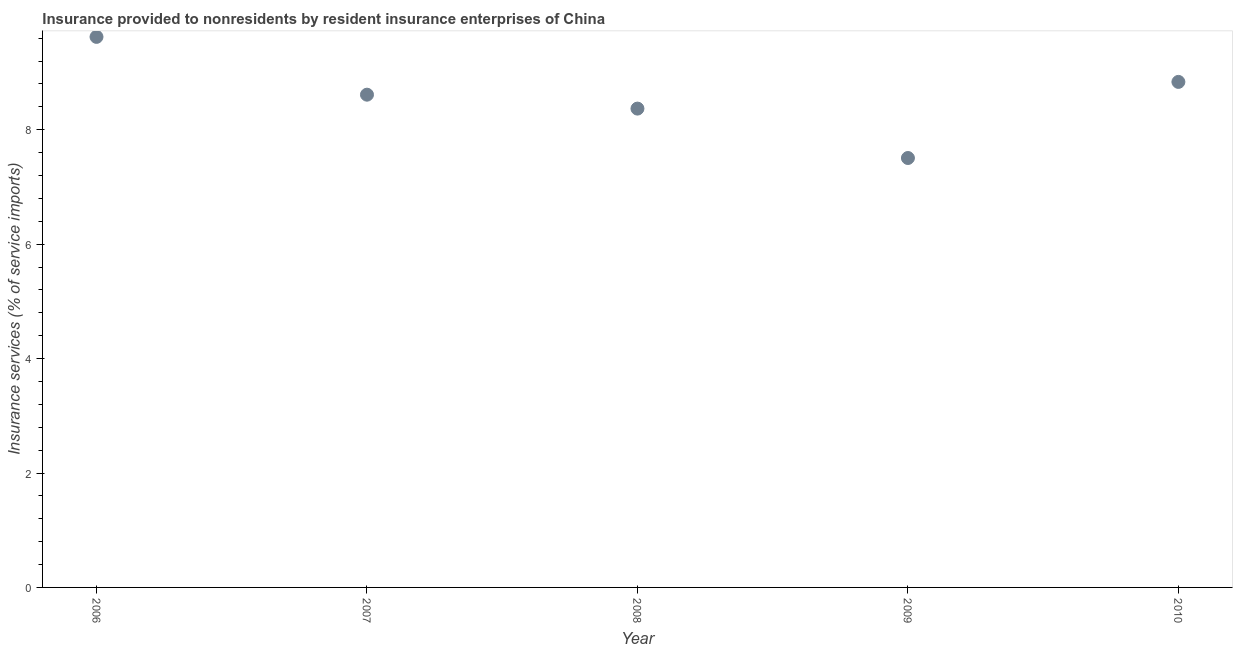What is the insurance and financial services in 2010?
Give a very brief answer. 8.84. Across all years, what is the maximum insurance and financial services?
Your answer should be compact. 9.62. Across all years, what is the minimum insurance and financial services?
Keep it short and to the point. 7.51. What is the sum of the insurance and financial services?
Provide a succinct answer. 42.95. What is the difference between the insurance and financial services in 2007 and 2009?
Offer a terse response. 1.11. What is the average insurance and financial services per year?
Offer a terse response. 8.59. What is the median insurance and financial services?
Your answer should be compact. 8.61. In how many years, is the insurance and financial services greater than 6.8 %?
Keep it short and to the point. 5. What is the ratio of the insurance and financial services in 2007 to that in 2008?
Your answer should be compact. 1.03. What is the difference between the highest and the second highest insurance and financial services?
Your answer should be very brief. 0.79. Is the sum of the insurance and financial services in 2009 and 2010 greater than the maximum insurance and financial services across all years?
Your answer should be very brief. Yes. What is the difference between the highest and the lowest insurance and financial services?
Provide a short and direct response. 2.12. How many dotlines are there?
Provide a succinct answer. 1. How many years are there in the graph?
Offer a very short reply. 5. Are the values on the major ticks of Y-axis written in scientific E-notation?
Give a very brief answer. No. Does the graph contain grids?
Give a very brief answer. No. What is the title of the graph?
Keep it short and to the point. Insurance provided to nonresidents by resident insurance enterprises of China. What is the label or title of the X-axis?
Make the answer very short. Year. What is the label or title of the Y-axis?
Provide a short and direct response. Insurance services (% of service imports). What is the Insurance services (% of service imports) in 2006?
Provide a short and direct response. 9.62. What is the Insurance services (% of service imports) in 2007?
Offer a very short reply. 8.61. What is the Insurance services (% of service imports) in 2008?
Your answer should be compact. 8.37. What is the Insurance services (% of service imports) in 2009?
Your response must be concise. 7.51. What is the Insurance services (% of service imports) in 2010?
Ensure brevity in your answer.  8.84. What is the difference between the Insurance services (% of service imports) in 2006 and 2007?
Make the answer very short. 1.01. What is the difference between the Insurance services (% of service imports) in 2006 and 2008?
Your answer should be very brief. 1.25. What is the difference between the Insurance services (% of service imports) in 2006 and 2009?
Offer a terse response. 2.12. What is the difference between the Insurance services (% of service imports) in 2006 and 2010?
Give a very brief answer. 0.79. What is the difference between the Insurance services (% of service imports) in 2007 and 2008?
Your answer should be very brief. 0.24. What is the difference between the Insurance services (% of service imports) in 2007 and 2009?
Make the answer very short. 1.11. What is the difference between the Insurance services (% of service imports) in 2007 and 2010?
Your response must be concise. -0.22. What is the difference between the Insurance services (% of service imports) in 2008 and 2009?
Ensure brevity in your answer.  0.86. What is the difference between the Insurance services (% of service imports) in 2008 and 2010?
Provide a short and direct response. -0.47. What is the difference between the Insurance services (% of service imports) in 2009 and 2010?
Provide a short and direct response. -1.33. What is the ratio of the Insurance services (% of service imports) in 2006 to that in 2007?
Offer a terse response. 1.12. What is the ratio of the Insurance services (% of service imports) in 2006 to that in 2008?
Give a very brief answer. 1.15. What is the ratio of the Insurance services (% of service imports) in 2006 to that in 2009?
Your answer should be very brief. 1.28. What is the ratio of the Insurance services (% of service imports) in 2006 to that in 2010?
Your response must be concise. 1.09. What is the ratio of the Insurance services (% of service imports) in 2007 to that in 2008?
Your answer should be compact. 1.03. What is the ratio of the Insurance services (% of service imports) in 2007 to that in 2009?
Offer a very short reply. 1.15. What is the ratio of the Insurance services (% of service imports) in 2007 to that in 2010?
Keep it short and to the point. 0.97. What is the ratio of the Insurance services (% of service imports) in 2008 to that in 2009?
Give a very brief answer. 1.11. What is the ratio of the Insurance services (% of service imports) in 2008 to that in 2010?
Ensure brevity in your answer.  0.95. What is the ratio of the Insurance services (% of service imports) in 2009 to that in 2010?
Offer a terse response. 0.85. 